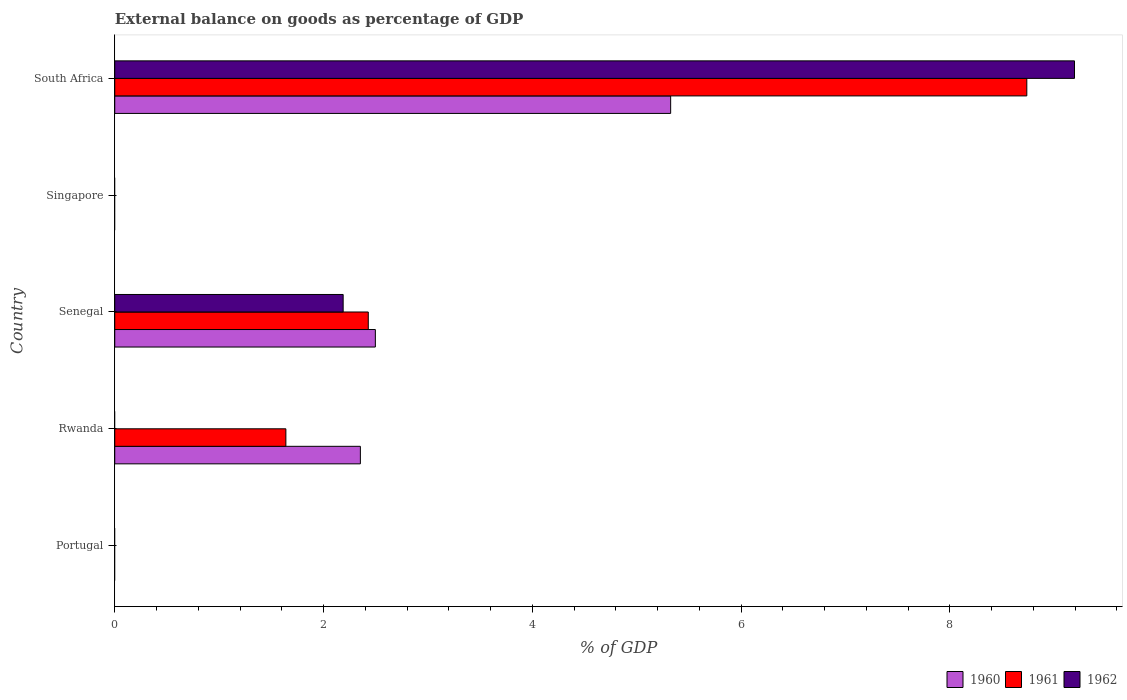How many different coloured bars are there?
Ensure brevity in your answer.  3. What is the label of the 5th group of bars from the top?
Your answer should be compact. Portugal. What is the external balance on goods as percentage of GDP in 1960 in Senegal?
Make the answer very short. 2.5. Across all countries, what is the maximum external balance on goods as percentage of GDP in 1962?
Offer a terse response. 9.19. In which country was the external balance on goods as percentage of GDP in 1960 maximum?
Keep it short and to the point. South Africa. What is the total external balance on goods as percentage of GDP in 1961 in the graph?
Offer a terse response. 12.81. What is the difference between the external balance on goods as percentage of GDP in 1961 in Rwanda and that in South Africa?
Offer a terse response. -7.1. What is the difference between the external balance on goods as percentage of GDP in 1962 in Rwanda and the external balance on goods as percentage of GDP in 1960 in Senegal?
Your answer should be compact. -2.5. What is the average external balance on goods as percentage of GDP in 1960 per country?
Offer a terse response. 2.03. What is the difference between the external balance on goods as percentage of GDP in 1961 and external balance on goods as percentage of GDP in 1962 in South Africa?
Ensure brevity in your answer.  -0.46. What is the ratio of the external balance on goods as percentage of GDP in 1961 in Rwanda to that in Senegal?
Make the answer very short. 0.68. What is the difference between the highest and the second highest external balance on goods as percentage of GDP in 1961?
Provide a short and direct response. 6.31. What is the difference between the highest and the lowest external balance on goods as percentage of GDP in 1962?
Provide a short and direct response. 9.19. In how many countries, is the external balance on goods as percentage of GDP in 1960 greater than the average external balance on goods as percentage of GDP in 1960 taken over all countries?
Your answer should be very brief. 3. Is the sum of the external balance on goods as percentage of GDP in 1960 in Senegal and South Africa greater than the maximum external balance on goods as percentage of GDP in 1961 across all countries?
Give a very brief answer. No. Is it the case that in every country, the sum of the external balance on goods as percentage of GDP in 1962 and external balance on goods as percentage of GDP in 1960 is greater than the external balance on goods as percentage of GDP in 1961?
Provide a succinct answer. No. How many bars are there?
Offer a very short reply. 8. Are all the bars in the graph horizontal?
Ensure brevity in your answer.  Yes. How many countries are there in the graph?
Your response must be concise. 5. Does the graph contain grids?
Keep it short and to the point. No. Where does the legend appear in the graph?
Your response must be concise. Bottom right. How many legend labels are there?
Offer a very short reply. 3. How are the legend labels stacked?
Your answer should be compact. Horizontal. What is the title of the graph?
Your answer should be very brief. External balance on goods as percentage of GDP. Does "1967" appear as one of the legend labels in the graph?
Your answer should be very brief. No. What is the label or title of the X-axis?
Your response must be concise. % of GDP. What is the % of GDP in 1962 in Portugal?
Your answer should be compact. 0. What is the % of GDP of 1960 in Rwanda?
Give a very brief answer. 2.35. What is the % of GDP in 1961 in Rwanda?
Provide a short and direct response. 1.64. What is the % of GDP in 1960 in Senegal?
Make the answer very short. 2.5. What is the % of GDP in 1961 in Senegal?
Keep it short and to the point. 2.43. What is the % of GDP in 1962 in Senegal?
Your response must be concise. 2.19. What is the % of GDP in 1960 in South Africa?
Make the answer very short. 5.33. What is the % of GDP in 1961 in South Africa?
Offer a terse response. 8.74. What is the % of GDP in 1962 in South Africa?
Keep it short and to the point. 9.19. Across all countries, what is the maximum % of GDP in 1960?
Make the answer very short. 5.33. Across all countries, what is the maximum % of GDP of 1961?
Ensure brevity in your answer.  8.74. Across all countries, what is the maximum % of GDP of 1962?
Provide a short and direct response. 9.19. Across all countries, what is the minimum % of GDP in 1961?
Make the answer very short. 0. Across all countries, what is the minimum % of GDP of 1962?
Provide a short and direct response. 0. What is the total % of GDP of 1960 in the graph?
Offer a terse response. 10.17. What is the total % of GDP in 1961 in the graph?
Provide a short and direct response. 12.81. What is the total % of GDP in 1962 in the graph?
Provide a succinct answer. 11.38. What is the difference between the % of GDP in 1960 in Rwanda and that in Senegal?
Your response must be concise. -0.14. What is the difference between the % of GDP of 1961 in Rwanda and that in Senegal?
Ensure brevity in your answer.  -0.79. What is the difference between the % of GDP in 1960 in Rwanda and that in South Africa?
Provide a short and direct response. -2.97. What is the difference between the % of GDP in 1961 in Rwanda and that in South Africa?
Make the answer very short. -7.1. What is the difference between the % of GDP in 1960 in Senegal and that in South Africa?
Your answer should be compact. -2.83. What is the difference between the % of GDP of 1961 in Senegal and that in South Africa?
Offer a terse response. -6.31. What is the difference between the % of GDP in 1962 in Senegal and that in South Africa?
Offer a very short reply. -7.01. What is the difference between the % of GDP in 1960 in Rwanda and the % of GDP in 1961 in Senegal?
Provide a succinct answer. -0.08. What is the difference between the % of GDP in 1960 in Rwanda and the % of GDP in 1962 in Senegal?
Provide a succinct answer. 0.16. What is the difference between the % of GDP in 1961 in Rwanda and the % of GDP in 1962 in Senegal?
Make the answer very short. -0.55. What is the difference between the % of GDP of 1960 in Rwanda and the % of GDP of 1961 in South Africa?
Offer a terse response. -6.38. What is the difference between the % of GDP of 1960 in Rwanda and the % of GDP of 1962 in South Africa?
Give a very brief answer. -6.84. What is the difference between the % of GDP in 1961 in Rwanda and the % of GDP in 1962 in South Africa?
Your answer should be very brief. -7.55. What is the difference between the % of GDP of 1960 in Senegal and the % of GDP of 1961 in South Africa?
Offer a very short reply. -6.24. What is the difference between the % of GDP of 1960 in Senegal and the % of GDP of 1962 in South Africa?
Give a very brief answer. -6.7. What is the difference between the % of GDP in 1961 in Senegal and the % of GDP in 1962 in South Africa?
Keep it short and to the point. -6.77. What is the average % of GDP of 1960 per country?
Your response must be concise. 2.04. What is the average % of GDP in 1961 per country?
Give a very brief answer. 2.56. What is the average % of GDP of 1962 per country?
Give a very brief answer. 2.28. What is the difference between the % of GDP of 1960 and % of GDP of 1961 in Rwanda?
Offer a terse response. 0.71. What is the difference between the % of GDP in 1960 and % of GDP in 1961 in Senegal?
Your answer should be compact. 0.07. What is the difference between the % of GDP of 1960 and % of GDP of 1962 in Senegal?
Provide a short and direct response. 0.31. What is the difference between the % of GDP of 1961 and % of GDP of 1962 in Senegal?
Your response must be concise. 0.24. What is the difference between the % of GDP of 1960 and % of GDP of 1961 in South Africa?
Your response must be concise. -3.41. What is the difference between the % of GDP in 1960 and % of GDP in 1962 in South Africa?
Offer a terse response. -3.87. What is the difference between the % of GDP in 1961 and % of GDP in 1962 in South Africa?
Your response must be concise. -0.46. What is the ratio of the % of GDP of 1960 in Rwanda to that in Senegal?
Offer a terse response. 0.94. What is the ratio of the % of GDP of 1961 in Rwanda to that in Senegal?
Keep it short and to the point. 0.68. What is the ratio of the % of GDP in 1960 in Rwanda to that in South Africa?
Offer a very short reply. 0.44. What is the ratio of the % of GDP of 1961 in Rwanda to that in South Africa?
Make the answer very short. 0.19. What is the ratio of the % of GDP in 1960 in Senegal to that in South Africa?
Provide a short and direct response. 0.47. What is the ratio of the % of GDP in 1961 in Senegal to that in South Africa?
Offer a terse response. 0.28. What is the ratio of the % of GDP of 1962 in Senegal to that in South Africa?
Provide a short and direct response. 0.24. What is the difference between the highest and the second highest % of GDP of 1960?
Offer a terse response. 2.83. What is the difference between the highest and the second highest % of GDP in 1961?
Give a very brief answer. 6.31. What is the difference between the highest and the lowest % of GDP of 1960?
Keep it short and to the point. 5.33. What is the difference between the highest and the lowest % of GDP of 1961?
Provide a succinct answer. 8.74. What is the difference between the highest and the lowest % of GDP in 1962?
Offer a terse response. 9.19. 